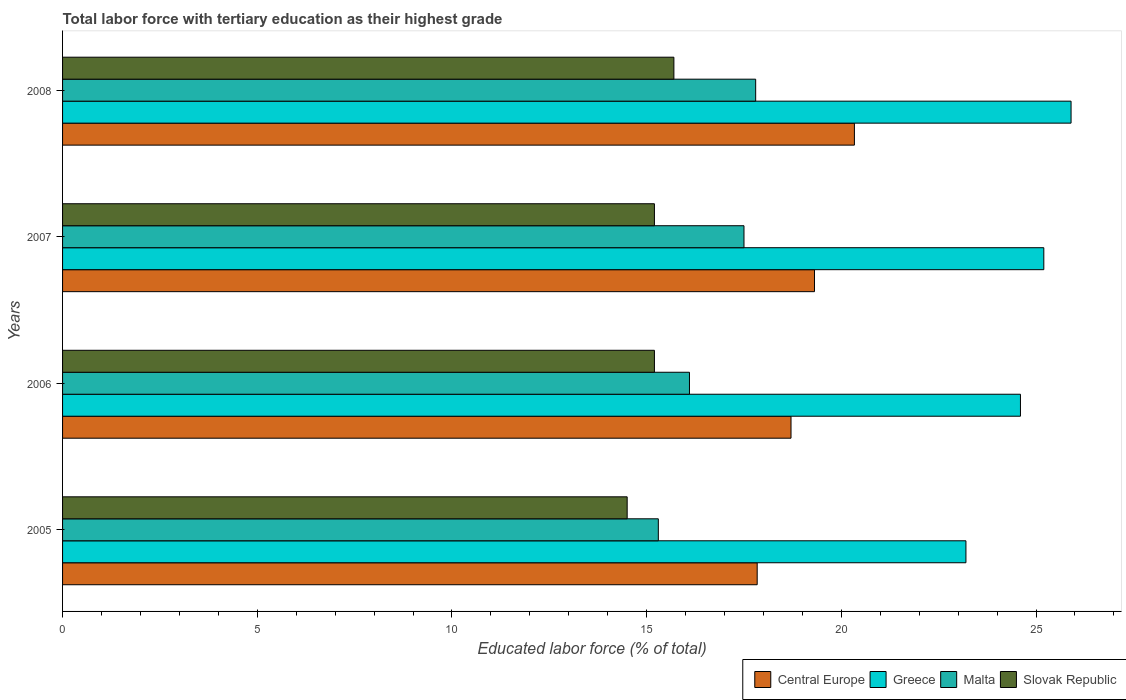In how many cases, is the number of bars for a given year not equal to the number of legend labels?
Ensure brevity in your answer.  0. What is the percentage of male labor force with tertiary education in Malta in 2005?
Keep it short and to the point. 15.3. Across all years, what is the maximum percentage of male labor force with tertiary education in Malta?
Give a very brief answer. 17.8. Across all years, what is the minimum percentage of male labor force with tertiary education in Malta?
Your answer should be compact. 15.3. What is the total percentage of male labor force with tertiary education in Malta in the graph?
Provide a succinct answer. 66.7. What is the difference between the percentage of male labor force with tertiary education in Central Europe in 2005 and that in 2008?
Provide a succinct answer. -2.5. What is the difference between the percentage of male labor force with tertiary education in Malta in 2005 and the percentage of male labor force with tertiary education in Greece in 2008?
Provide a short and direct response. -10.6. What is the average percentage of male labor force with tertiary education in Greece per year?
Keep it short and to the point. 24.73. In the year 2007, what is the difference between the percentage of male labor force with tertiary education in Central Europe and percentage of male labor force with tertiary education in Slovak Republic?
Provide a succinct answer. 4.11. What is the ratio of the percentage of male labor force with tertiary education in Malta in 2006 to that in 2008?
Provide a short and direct response. 0.9. Is the difference between the percentage of male labor force with tertiary education in Central Europe in 2005 and 2007 greater than the difference between the percentage of male labor force with tertiary education in Slovak Republic in 2005 and 2007?
Your response must be concise. No. What is the difference between the highest and the second highest percentage of male labor force with tertiary education in Slovak Republic?
Your answer should be very brief. 0.5. What is the difference between the highest and the lowest percentage of male labor force with tertiary education in Greece?
Give a very brief answer. 2.7. Is the sum of the percentage of male labor force with tertiary education in Central Europe in 2005 and 2006 greater than the maximum percentage of male labor force with tertiary education in Malta across all years?
Make the answer very short. Yes. What does the 4th bar from the top in 2005 represents?
Your answer should be compact. Central Europe. What does the 3rd bar from the bottom in 2008 represents?
Make the answer very short. Malta. Are all the bars in the graph horizontal?
Give a very brief answer. Yes. Where does the legend appear in the graph?
Your response must be concise. Bottom right. How many legend labels are there?
Ensure brevity in your answer.  4. How are the legend labels stacked?
Keep it short and to the point. Horizontal. What is the title of the graph?
Make the answer very short. Total labor force with tertiary education as their highest grade. What is the label or title of the X-axis?
Your answer should be compact. Educated labor force (% of total). What is the Educated labor force (% of total) of Central Europe in 2005?
Provide a succinct answer. 17.84. What is the Educated labor force (% of total) of Greece in 2005?
Make the answer very short. 23.2. What is the Educated labor force (% of total) in Malta in 2005?
Make the answer very short. 15.3. What is the Educated labor force (% of total) in Slovak Republic in 2005?
Your answer should be very brief. 14.5. What is the Educated labor force (% of total) in Central Europe in 2006?
Your answer should be compact. 18.71. What is the Educated labor force (% of total) of Greece in 2006?
Ensure brevity in your answer.  24.6. What is the Educated labor force (% of total) in Malta in 2006?
Your answer should be compact. 16.1. What is the Educated labor force (% of total) in Slovak Republic in 2006?
Give a very brief answer. 15.2. What is the Educated labor force (% of total) in Central Europe in 2007?
Offer a very short reply. 19.31. What is the Educated labor force (% of total) in Greece in 2007?
Provide a short and direct response. 25.2. What is the Educated labor force (% of total) in Slovak Republic in 2007?
Keep it short and to the point. 15.2. What is the Educated labor force (% of total) in Central Europe in 2008?
Offer a very short reply. 20.34. What is the Educated labor force (% of total) of Greece in 2008?
Your answer should be compact. 25.9. What is the Educated labor force (% of total) in Malta in 2008?
Provide a short and direct response. 17.8. What is the Educated labor force (% of total) of Slovak Republic in 2008?
Your answer should be compact. 15.7. Across all years, what is the maximum Educated labor force (% of total) in Central Europe?
Make the answer very short. 20.34. Across all years, what is the maximum Educated labor force (% of total) of Greece?
Provide a short and direct response. 25.9. Across all years, what is the maximum Educated labor force (% of total) of Malta?
Your answer should be compact. 17.8. Across all years, what is the maximum Educated labor force (% of total) in Slovak Republic?
Your answer should be very brief. 15.7. Across all years, what is the minimum Educated labor force (% of total) in Central Europe?
Ensure brevity in your answer.  17.84. Across all years, what is the minimum Educated labor force (% of total) in Greece?
Ensure brevity in your answer.  23.2. Across all years, what is the minimum Educated labor force (% of total) in Malta?
Your answer should be compact. 15.3. Across all years, what is the minimum Educated labor force (% of total) of Slovak Republic?
Offer a terse response. 14.5. What is the total Educated labor force (% of total) of Central Europe in the graph?
Your answer should be compact. 76.19. What is the total Educated labor force (% of total) of Greece in the graph?
Your answer should be compact. 98.9. What is the total Educated labor force (% of total) of Malta in the graph?
Make the answer very short. 66.7. What is the total Educated labor force (% of total) of Slovak Republic in the graph?
Keep it short and to the point. 60.6. What is the difference between the Educated labor force (% of total) in Central Europe in 2005 and that in 2006?
Your response must be concise. -0.87. What is the difference between the Educated labor force (% of total) of Greece in 2005 and that in 2006?
Ensure brevity in your answer.  -1.4. What is the difference between the Educated labor force (% of total) in Slovak Republic in 2005 and that in 2006?
Offer a terse response. -0.7. What is the difference between the Educated labor force (% of total) in Central Europe in 2005 and that in 2007?
Offer a terse response. -1.47. What is the difference between the Educated labor force (% of total) in Greece in 2005 and that in 2007?
Keep it short and to the point. -2. What is the difference between the Educated labor force (% of total) of Malta in 2005 and that in 2007?
Make the answer very short. -2.2. What is the difference between the Educated labor force (% of total) in Central Europe in 2005 and that in 2008?
Ensure brevity in your answer.  -2.5. What is the difference between the Educated labor force (% of total) of Greece in 2005 and that in 2008?
Your answer should be compact. -2.7. What is the difference between the Educated labor force (% of total) of Central Europe in 2006 and that in 2007?
Provide a short and direct response. -0.6. What is the difference between the Educated labor force (% of total) of Greece in 2006 and that in 2007?
Offer a very short reply. -0.6. What is the difference between the Educated labor force (% of total) in Malta in 2006 and that in 2007?
Your answer should be compact. -1.4. What is the difference between the Educated labor force (% of total) of Central Europe in 2006 and that in 2008?
Your answer should be compact. -1.63. What is the difference between the Educated labor force (% of total) of Greece in 2006 and that in 2008?
Ensure brevity in your answer.  -1.3. What is the difference between the Educated labor force (% of total) in Central Europe in 2007 and that in 2008?
Provide a short and direct response. -1.03. What is the difference between the Educated labor force (% of total) of Malta in 2007 and that in 2008?
Make the answer very short. -0.3. What is the difference between the Educated labor force (% of total) of Slovak Republic in 2007 and that in 2008?
Provide a short and direct response. -0.5. What is the difference between the Educated labor force (% of total) of Central Europe in 2005 and the Educated labor force (% of total) of Greece in 2006?
Your answer should be very brief. -6.76. What is the difference between the Educated labor force (% of total) of Central Europe in 2005 and the Educated labor force (% of total) of Malta in 2006?
Offer a very short reply. 1.74. What is the difference between the Educated labor force (% of total) in Central Europe in 2005 and the Educated labor force (% of total) in Slovak Republic in 2006?
Keep it short and to the point. 2.64. What is the difference between the Educated labor force (% of total) in Central Europe in 2005 and the Educated labor force (% of total) in Greece in 2007?
Your response must be concise. -7.36. What is the difference between the Educated labor force (% of total) in Central Europe in 2005 and the Educated labor force (% of total) in Malta in 2007?
Offer a very short reply. 0.34. What is the difference between the Educated labor force (% of total) of Central Europe in 2005 and the Educated labor force (% of total) of Slovak Republic in 2007?
Your response must be concise. 2.64. What is the difference between the Educated labor force (% of total) in Greece in 2005 and the Educated labor force (% of total) in Malta in 2007?
Ensure brevity in your answer.  5.7. What is the difference between the Educated labor force (% of total) in Malta in 2005 and the Educated labor force (% of total) in Slovak Republic in 2007?
Your answer should be compact. 0.1. What is the difference between the Educated labor force (% of total) in Central Europe in 2005 and the Educated labor force (% of total) in Greece in 2008?
Make the answer very short. -8.06. What is the difference between the Educated labor force (% of total) in Central Europe in 2005 and the Educated labor force (% of total) in Malta in 2008?
Keep it short and to the point. 0.04. What is the difference between the Educated labor force (% of total) of Central Europe in 2005 and the Educated labor force (% of total) of Slovak Republic in 2008?
Offer a very short reply. 2.14. What is the difference between the Educated labor force (% of total) in Greece in 2005 and the Educated labor force (% of total) in Slovak Republic in 2008?
Keep it short and to the point. 7.5. What is the difference between the Educated labor force (% of total) of Central Europe in 2006 and the Educated labor force (% of total) of Greece in 2007?
Your answer should be very brief. -6.49. What is the difference between the Educated labor force (% of total) in Central Europe in 2006 and the Educated labor force (% of total) in Malta in 2007?
Keep it short and to the point. 1.21. What is the difference between the Educated labor force (% of total) of Central Europe in 2006 and the Educated labor force (% of total) of Slovak Republic in 2007?
Keep it short and to the point. 3.51. What is the difference between the Educated labor force (% of total) of Greece in 2006 and the Educated labor force (% of total) of Slovak Republic in 2007?
Offer a very short reply. 9.4. What is the difference between the Educated labor force (% of total) of Malta in 2006 and the Educated labor force (% of total) of Slovak Republic in 2007?
Give a very brief answer. 0.9. What is the difference between the Educated labor force (% of total) of Central Europe in 2006 and the Educated labor force (% of total) of Greece in 2008?
Offer a terse response. -7.19. What is the difference between the Educated labor force (% of total) of Central Europe in 2006 and the Educated labor force (% of total) of Malta in 2008?
Provide a succinct answer. 0.91. What is the difference between the Educated labor force (% of total) in Central Europe in 2006 and the Educated labor force (% of total) in Slovak Republic in 2008?
Offer a very short reply. 3.01. What is the difference between the Educated labor force (% of total) in Greece in 2006 and the Educated labor force (% of total) in Malta in 2008?
Your answer should be very brief. 6.8. What is the difference between the Educated labor force (% of total) in Greece in 2006 and the Educated labor force (% of total) in Slovak Republic in 2008?
Make the answer very short. 8.9. What is the difference between the Educated labor force (% of total) in Central Europe in 2007 and the Educated labor force (% of total) in Greece in 2008?
Provide a short and direct response. -6.59. What is the difference between the Educated labor force (% of total) in Central Europe in 2007 and the Educated labor force (% of total) in Malta in 2008?
Your answer should be very brief. 1.51. What is the difference between the Educated labor force (% of total) in Central Europe in 2007 and the Educated labor force (% of total) in Slovak Republic in 2008?
Your response must be concise. 3.61. What is the difference between the Educated labor force (% of total) in Greece in 2007 and the Educated labor force (% of total) in Malta in 2008?
Give a very brief answer. 7.4. What is the difference between the Educated labor force (% of total) in Greece in 2007 and the Educated labor force (% of total) in Slovak Republic in 2008?
Provide a succinct answer. 9.5. What is the average Educated labor force (% of total) of Central Europe per year?
Provide a succinct answer. 19.05. What is the average Educated labor force (% of total) in Greece per year?
Provide a succinct answer. 24.73. What is the average Educated labor force (% of total) in Malta per year?
Make the answer very short. 16.68. What is the average Educated labor force (% of total) in Slovak Republic per year?
Offer a terse response. 15.15. In the year 2005, what is the difference between the Educated labor force (% of total) in Central Europe and Educated labor force (% of total) in Greece?
Offer a very short reply. -5.36. In the year 2005, what is the difference between the Educated labor force (% of total) of Central Europe and Educated labor force (% of total) of Malta?
Ensure brevity in your answer.  2.54. In the year 2005, what is the difference between the Educated labor force (% of total) of Central Europe and Educated labor force (% of total) of Slovak Republic?
Offer a very short reply. 3.34. In the year 2005, what is the difference between the Educated labor force (% of total) in Greece and Educated labor force (% of total) in Malta?
Ensure brevity in your answer.  7.9. In the year 2005, what is the difference between the Educated labor force (% of total) of Malta and Educated labor force (% of total) of Slovak Republic?
Keep it short and to the point. 0.8. In the year 2006, what is the difference between the Educated labor force (% of total) in Central Europe and Educated labor force (% of total) in Greece?
Keep it short and to the point. -5.89. In the year 2006, what is the difference between the Educated labor force (% of total) in Central Europe and Educated labor force (% of total) in Malta?
Your answer should be compact. 2.61. In the year 2006, what is the difference between the Educated labor force (% of total) of Central Europe and Educated labor force (% of total) of Slovak Republic?
Give a very brief answer. 3.51. In the year 2006, what is the difference between the Educated labor force (% of total) of Greece and Educated labor force (% of total) of Malta?
Ensure brevity in your answer.  8.5. In the year 2006, what is the difference between the Educated labor force (% of total) of Greece and Educated labor force (% of total) of Slovak Republic?
Your answer should be very brief. 9.4. In the year 2006, what is the difference between the Educated labor force (% of total) in Malta and Educated labor force (% of total) in Slovak Republic?
Your response must be concise. 0.9. In the year 2007, what is the difference between the Educated labor force (% of total) in Central Europe and Educated labor force (% of total) in Greece?
Give a very brief answer. -5.89. In the year 2007, what is the difference between the Educated labor force (% of total) in Central Europe and Educated labor force (% of total) in Malta?
Offer a terse response. 1.81. In the year 2007, what is the difference between the Educated labor force (% of total) of Central Europe and Educated labor force (% of total) of Slovak Republic?
Offer a terse response. 4.11. In the year 2007, what is the difference between the Educated labor force (% of total) of Greece and Educated labor force (% of total) of Slovak Republic?
Offer a terse response. 10. In the year 2007, what is the difference between the Educated labor force (% of total) of Malta and Educated labor force (% of total) of Slovak Republic?
Ensure brevity in your answer.  2.3. In the year 2008, what is the difference between the Educated labor force (% of total) in Central Europe and Educated labor force (% of total) in Greece?
Your response must be concise. -5.56. In the year 2008, what is the difference between the Educated labor force (% of total) in Central Europe and Educated labor force (% of total) in Malta?
Provide a succinct answer. 2.54. In the year 2008, what is the difference between the Educated labor force (% of total) in Central Europe and Educated labor force (% of total) in Slovak Republic?
Give a very brief answer. 4.64. In the year 2008, what is the difference between the Educated labor force (% of total) in Greece and Educated labor force (% of total) in Malta?
Give a very brief answer. 8.1. In the year 2008, what is the difference between the Educated labor force (% of total) in Greece and Educated labor force (% of total) in Slovak Republic?
Give a very brief answer. 10.2. In the year 2008, what is the difference between the Educated labor force (% of total) of Malta and Educated labor force (% of total) of Slovak Republic?
Make the answer very short. 2.1. What is the ratio of the Educated labor force (% of total) in Central Europe in 2005 to that in 2006?
Ensure brevity in your answer.  0.95. What is the ratio of the Educated labor force (% of total) of Greece in 2005 to that in 2006?
Your response must be concise. 0.94. What is the ratio of the Educated labor force (% of total) of Malta in 2005 to that in 2006?
Provide a short and direct response. 0.95. What is the ratio of the Educated labor force (% of total) of Slovak Republic in 2005 to that in 2006?
Provide a succinct answer. 0.95. What is the ratio of the Educated labor force (% of total) of Central Europe in 2005 to that in 2007?
Offer a terse response. 0.92. What is the ratio of the Educated labor force (% of total) in Greece in 2005 to that in 2007?
Your response must be concise. 0.92. What is the ratio of the Educated labor force (% of total) in Malta in 2005 to that in 2007?
Provide a short and direct response. 0.87. What is the ratio of the Educated labor force (% of total) in Slovak Republic in 2005 to that in 2007?
Offer a terse response. 0.95. What is the ratio of the Educated labor force (% of total) of Central Europe in 2005 to that in 2008?
Your answer should be very brief. 0.88. What is the ratio of the Educated labor force (% of total) of Greece in 2005 to that in 2008?
Give a very brief answer. 0.9. What is the ratio of the Educated labor force (% of total) of Malta in 2005 to that in 2008?
Make the answer very short. 0.86. What is the ratio of the Educated labor force (% of total) of Slovak Republic in 2005 to that in 2008?
Give a very brief answer. 0.92. What is the ratio of the Educated labor force (% of total) of Central Europe in 2006 to that in 2007?
Keep it short and to the point. 0.97. What is the ratio of the Educated labor force (% of total) in Greece in 2006 to that in 2007?
Offer a terse response. 0.98. What is the ratio of the Educated labor force (% of total) of Slovak Republic in 2006 to that in 2007?
Provide a succinct answer. 1. What is the ratio of the Educated labor force (% of total) of Central Europe in 2006 to that in 2008?
Offer a terse response. 0.92. What is the ratio of the Educated labor force (% of total) of Greece in 2006 to that in 2008?
Make the answer very short. 0.95. What is the ratio of the Educated labor force (% of total) of Malta in 2006 to that in 2008?
Make the answer very short. 0.9. What is the ratio of the Educated labor force (% of total) of Slovak Republic in 2006 to that in 2008?
Give a very brief answer. 0.97. What is the ratio of the Educated labor force (% of total) of Central Europe in 2007 to that in 2008?
Your answer should be compact. 0.95. What is the ratio of the Educated labor force (% of total) in Greece in 2007 to that in 2008?
Your response must be concise. 0.97. What is the ratio of the Educated labor force (% of total) of Malta in 2007 to that in 2008?
Give a very brief answer. 0.98. What is the ratio of the Educated labor force (% of total) of Slovak Republic in 2007 to that in 2008?
Make the answer very short. 0.97. What is the difference between the highest and the second highest Educated labor force (% of total) in Central Europe?
Provide a short and direct response. 1.03. What is the difference between the highest and the second highest Educated labor force (% of total) of Greece?
Offer a very short reply. 0.7. What is the difference between the highest and the second highest Educated labor force (% of total) in Malta?
Offer a very short reply. 0.3. What is the difference between the highest and the second highest Educated labor force (% of total) of Slovak Republic?
Your answer should be compact. 0.5. What is the difference between the highest and the lowest Educated labor force (% of total) of Central Europe?
Offer a terse response. 2.5. What is the difference between the highest and the lowest Educated labor force (% of total) of Greece?
Keep it short and to the point. 2.7. What is the difference between the highest and the lowest Educated labor force (% of total) of Slovak Republic?
Offer a terse response. 1.2. 